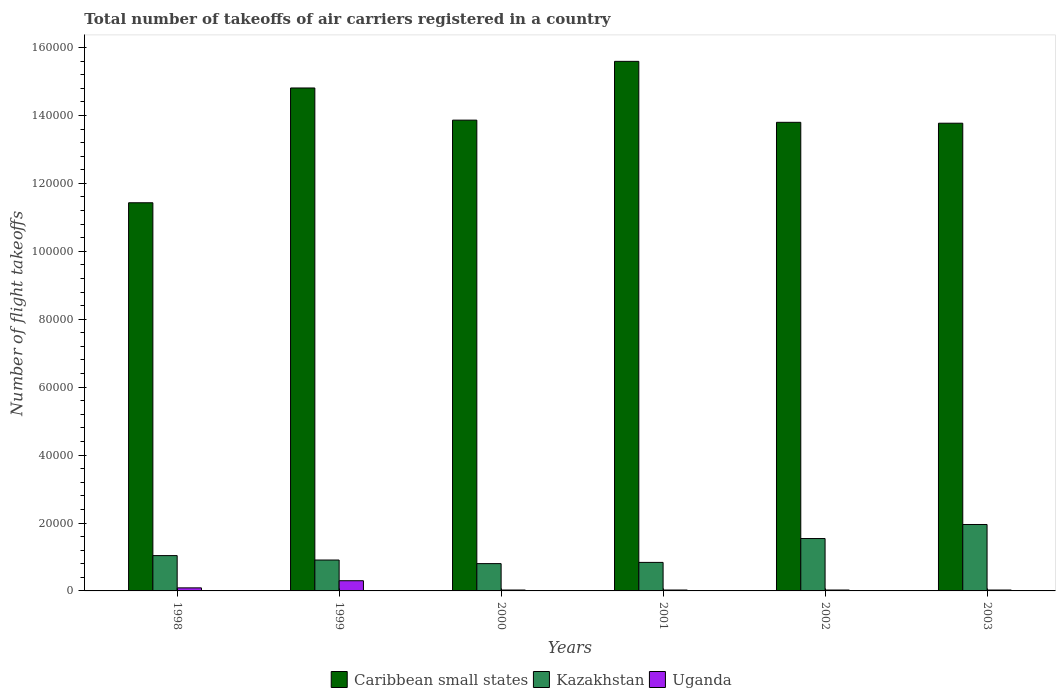How many different coloured bars are there?
Provide a succinct answer. 3. What is the label of the 1st group of bars from the left?
Provide a short and direct response. 1998. In how many cases, is the number of bars for a given year not equal to the number of legend labels?
Provide a succinct answer. 0. What is the total number of flight takeoffs in Uganda in 2002?
Keep it short and to the point. 263. Across all years, what is the maximum total number of flight takeoffs in Kazakhstan?
Offer a very short reply. 1.96e+04. Across all years, what is the minimum total number of flight takeoffs in Caribbean small states?
Offer a very short reply. 1.14e+05. In which year was the total number of flight takeoffs in Caribbean small states minimum?
Provide a succinct answer. 1998. What is the total total number of flight takeoffs in Kazakhstan in the graph?
Your answer should be very brief. 7.09e+04. What is the difference between the total number of flight takeoffs in Uganda in 2001 and that in 2002?
Offer a terse response. 3. What is the difference between the total number of flight takeoffs in Uganda in 2003 and the total number of flight takeoffs in Kazakhstan in 2002?
Offer a very short reply. -1.52e+04. What is the average total number of flight takeoffs in Caribbean small states per year?
Ensure brevity in your answer.  1.39e+05. In the year 1998, what is the difference between the total number of flight takeoffs in Uganda and total number of flight takeoffs in Kazakhstan?
Keep it short and to the point. -9500. What is the ratio of the total number of flight takeoffs in Caribbean small states in 2002 to that in 2003?
Provide a succinct answer. 1. Is the total number of flight takeoffs in Uganda in 1999 less than that in 2003?
Provide a succinct answer. No. Is the difference between the total number of flight takeoffs in Uganda in 1998 and 2001 greater than the difference between the total number of flight takeoffs in Kazakhstan in 1998 and 2001?
Ensure brevity in your answer.  No. What is the difference between the highest and the second highest total number of flight takeoffs in Kazakhstan?
Keep it short and to the point. 4134. What is the difference between the highest and the lowest total number of flight takeoffs in Caribbean small states?
Your answer should be very brief. 4.16e+04. In how many years, is the total number of flight takeoffs in Uganda greater than the average total number of flight takeoffs in Uganda taken over all years?
Keep it short and to the point. 2. Is the sum of the total number of flight takeoffs in Uganda in 1998 and 2002 greater than the maximum total number of flight takeoffs in Kazakhstan across all years?
Offer a very short reply. No. What does the 3rd bar from the left in 2002 represents?
Keep it short and to the point. Uganda. What does the 2nd bar from the right in 2000 represents?
Ensure brevity in your answer.  Kazakhstan. Is it the case that in every year, the sum of the total number of flight takeoffs in Caribbean small states and total number of flight takeoffs in Uganda is greater than the total number of flight takeoffs in Kazakhstan?
Make the answer very short. Yes. Are all the bars in the graph horizontal?
Your answer should be compact. No. How many years are there in the graph?
Your response must be concise. 6. What is the difference between two consecutive major ticks on the Y-axis?
Your response must be concise. 2.00e+04. Are the values on the major ticks of Y-axis written in scientific E-notation?
Your answer should be very brief. No. Does the graph contain any zero values?
Offer a terse response. No. Does the graph contain grids?
Your answer should be compact. No. Where does the legend appear in the graph?
Make the answer very short. Bottom center. How many legend labels are there?
Keep it short and to the point. 3. What is the title of the graph?
Provide a short and direct response. Total number of takeoffs of air carriers registered in a country. What is the label or title of the Y-axis?
Keep it short and to the point. Number of flight takeoffs. What is the Number of flight takeoffs of Caribbean small states in 1998?
Your response must be concise. 1.14e+05. What is the Number of flight takeoffs of Kazakhstan in 1998?
Your answer should be very brief. 1.04e+04. What is the Number of flight takeoffs of Uganda in 1998?
Make the answer very short. 900. What is the Number of flight takeoffs in Caribbean small states in 1999?
Provide a short and direct response. 1.48e+05. What is the Number of flight takeoffs of Kazakhstan in 1999?
Offer a terse response. 9100. What is the Number of flight takeoffs in Uganda in 1999?
Provide a short and direct response. 3000. What is the Number of flight takeoffs in Caribbean small states in 2000?
Your answer should be compact. 1.39e+05. What is the Number of flight takeoffs in Kazakhstan in 2000?
Give a very brief answer. 8041. What is the Number of flight takeoffs of Uganda in 2000?
Your response must be concise. 263. What is the Number of flight takeoffs in Caribbean small states in 2001?
Your answer should be compact. 1.56e+05. What is the Number of flight takeoffs in Kazakhstan in 2001?
Your response must be concise. 8398. What is the Number of flight takeoffs of Uganda in 2001?
Provide a short and direct response. 266. What is the Number of flight takeoffs in Caribbean small states in 2002?
Give a very brief answer. 1.38e+05. What is the Number of flight takeoffs in Kazakhstan in 2002?
Ensure brevity in your answer.  1.54e+04. What is the Number of flight takeoffs of Uganda in 2002?
Offer a very short reply. 263. What is the Number of flight takeoffs of Caribbean small states in 2003?
Provide a succinct answer. 1.38e+05. What is the Number of flight takeoffs of Kazakhstan in 2003?
Keep it short and to the point. 1.96e+04. What is the Number of flight takeoffs in Uganda in 2003?
Your answer should be compact. 263. Across all years, what is the maximum Number of flight takeoffs in Caribbean small states?
Your response must be concise. 1.56e+05. Across all years, what is the maximum Number of flight takeoffs in Kazakhstan?
Provide a short and direct response. 1.96e+04. Across all years, what is the maximum Number of flight takeoffs in Uganda?
Make the answer very short. 3000. Across all years, what is the minimum Number of flight takeoffs in Caribbean small states?
Offer a terse response. 1.14e+05. Across all years, what is the minimum Number of flight takeoffs in Kazakhstan?
Give a very brief answer. 8041. Across all years, what is the minimum Number of flight takeoffs in Uganda?
Give a very brief answer. 263. What is the total Number of flight takeoffs of Caribbean small states in the graph?
Offer a very short reply. 8.33e+05. What is the total Number of flight takeoffs of Kazakhstan in the graph?
Offer a very short reply. 7.09e+04. What is the total Number of flight takeoffs in Uganda in the graph?
Give a very brief answer. 4955. What is the difference between the Number of flight takeoffs in Caribbean small states in 1998 and that in 1999?
Your answer should be very brief. -3.38e+04. What is the difference between the Number of flight takeoffs in Kazakhstan in 1998 and that in 1999?
Offer a very short reply. 1300. What is the difference between the Number of flight takeoffs of Uganda in 1998 and that in 1999?
Keep it short and to the point. -2100. What is the difference between the Number of flight takeoffs in Caribbean small states in 1998 and that in 2000?
Offer a very short reply. -2.43e+04. What is the difference between the Number of flight takeoffs of Kazakhstan in 1998 and that in 2000?
Your answer should be compact. 2359. What is the difference between the Number of flight takeoffs of Uganda in 1998 and that in 2000?
Provide a short and direct response. 637. What is the difference between the Number of flight takeoffs of Caribbean small states in 1998 and that in 2001?
Your response must be concise. -4.16e+04. What is the difference between the Number of flight takeoffs in Kazakhstan in 1998 and that in 2001?
Provide a succinct answer. 2002. What is the difference between the Number of flight takeoffs in Uganda in 1998 and that in 2001?
Offer a very short reply. 634. What is the difference between the Number of flight takeoffs of Caribbean small states in 1998 and that in 2002?
Offer a very short reply. -2.37e+04. What is the difference between the Number of flight takeoffs of Kazakhstan in 1998 and that in 2002?
Give a very brief answer. -5026. What is the difference between the Number of flight takeoffs in Uganda in 1998 and that in 2002?
Provide a short and direct response. 637. What is the difference between the Number of flight takeoffs in Caribbean small states in 1998 and that in 2003?
Offer a very short reply. -2.34e+04. What is the difference between the Number of flight takeoffs in Kazakhstan in 1998 and that in 2003?
Ensure brevity in your answer.  -9160. What is the difference between the Number of flight takeoffs of Uganda in 1998 and that in 2003?
Provide a short and direct response. 637. What is the difference between the Number of flight takeoffs of Caribbean small states in 1999 and that in 2000?
Make the answer very short. 9468. What is the difference between the Number of flight takeoffs of Kazakhstan in 1999 and that in 2000?
Give a very brief answer. 1059. What is the difference between the Number of flight takeoffs of Uganda in 1999 and that in 2000?
Provide a short and direct response. 2737. What is the difference between the Number of flight takeoffs of Caribbean small states in 1999 and that in 2001?
Provide a succinct answer. -7840. What is the difference between the Number of flight takeoffs of Kazakhstan in 1999 and that in 2001?
Your answer should be very brief. 702. What is the difference between the Number of flight takeoffs in Uganda in 1999 and that in 2001?
Ensure brevity in your answer.  2734. What is the difference between the Number of flight takeoffs of Caribbean small states in 1999 and that in 2002?
Your answer should be very brief. 1.01e+04. What is the difference between the Number of flight takeoffs in Kazakhstan in 1999 and that in 2002?
Offer a very short reply. -6326. What is the difference between the Number of flight takeoffs of Uganda in 1999 and that in 2002?
Your response must be concise. 2737. What is the difference between the Number of flight takeoffs of Caribbean small states in 1999 and that in 2003?
Provide a short and direct response. 1.04e+04. What is the difference between the Number of flight takeoffs of Kazakhstan in 1999 and that in 2003?
Your response must be concise. -1.05e+04. What is the difference between the Number of flight takeoffs in Uganda in 1999 and that in 2003?
Offer a very short reply. 2737. What is the difference between the Number of flight takeoffs in Caribbean small states in 2000 and that in 2001?
Keep it short and to the point. -1.73e+04. What is the difference between the Number of flight takeoffs of Kazakhstan in 2000 and that in 2001?
Your answer should be very brief. -357. What is the difference between the Number of flight takeoffs of Uganda in 2000 and that in 2001?
Make the answer very short. -3. What is the difference between the Number of flight takeoffs in Caribbean small states in 2000 and that in 2002?
Ensure brevity in your answer.  645. What is the difference between the Number of flight takeoffs of Kazakhstan in 2000 and that in 2002?
Provide a short and direct response. -7385. What is the difference between the Number of flight takeoffs of Uganda in 2000 and that in 2002?
Provide a short and direct response. 0. What is the difference between the Number of flight takeoffs in Caribbean small states in 2000 and that in 2003?
Keep it short and to the point. 905. What is the difference between the Number of flight takeoffs of Kazakhstan in 2000 and that in 2003?
Make the answer very short. -1.15e+04. What is the difference between the Number of flight takeoffs of Caribbean small states in 2001 and that in 2002?
Keep it short and to the point. 1.80e+04. What is the difference between the Number of flight takeoffs of Kazakhstan in 2001 and that in 2002?
Provide a short and direct response. -7028. What is the difference between the Number of flight takeoffs of Uganda in 2001 and that in 2002?
Make the answer very short. 3. What is the difference between the Number of flight takeoffs of Caribbean small states in 2001 and that in 2003?
Ensure brevity in your answer.  1.82e+04. What is the difference between the Number of flight takeoffs of Kazakhstan in 2001 and that in 2003?
Ensure brevity in your answer.  -1.12e+04. What is the difference between the Number of flight takeoffs of Uganda in 2001 and that in 2003?
Your answer should be compact. 3. What is the difference between the Number of flight takeoffs of Caribbean small states in 2002 and that in 2003?
Provide a short and direct response. 260. What is the difference between the Number of flight takeoffs of Kazakhstan in 2002 and that in 2003?
Keep it short and to the point. -4134. What is the difference between the Number of flight takeoffs of Uganda in 2002 and that in 2003?
Give a very brief answer. 0. What is the difference between the Number of flight takeoffs of Caribbean small states in 1998 and the Number of flight takeoffs of Kazakhstan in 1999?
Offer a very short reply. 1.05e+05. What is the difference between the Number of flight takeoffs in Caribbean small states in 1998 and the Number of flight takeoffs in Uganda in 1999?
Offer a terse response. 1.11e+05. What is the difference between the Number of flight takeoffs of Kazakhstan in 1998 and the Number of flight takeoffs of Uganda in 1999?
Give a very brief answer. 7400. What is the difference between the Number of flight takeoffs in Caribbean small states in 1998 and the Number of flight takeoffs in Kazakhstan in 2000?
Make the answer very short. 1.06e+05. What is the difference between the Number of flight takeoffs of Caribbean small states in 1998 and the Number of flight takeoffs of Uganda in 2000?
Provide a short and direct response. 1.14e+05. What is the difference between the Number of flight takeoffs of Kazakhstan in 1998 and the Number of flight takeoffs of Uganda in 2000?
Make the answer very short. 1.01e+04. What is the difference between the Number of flight takeoffs of Caribbean small states in 1998 and the Number of flight takeoffs of Kazakhstan in 2001?
Make the answer very short. 1.06e+05. What is the difference between the Number of flight takeoffs in Caribbean small states in 1998 and the Number of flight takeoffs in Uganda in 2001?
Ensure brevity in your answer.  1.14e+05. What is the difference between the Number of flight takeoffs in Kazakhstan in 1998 and the Number of flight takeoffs in Uganda in 2001?
Your response must be concise. 1.01e+04. What is the difference between the Number of flight takeoffs of Caribbean small states in 1998 and the Number of flight takeoffs of Kazakhstan in 2002?
Provide a succinct answer. 9.89e+04. What is the difference between the Number of flight takeoffs in Caribbean small states in 1998 and the Number of flight takeoffs in Uganda in 2002?
Your answer should be compact. 1.14e+05. What is the difference between the Number of flight takeoffs in Kazakhstan in 1998 and the Number of flight takeoffs in Uganda in 2002?
Keep it short and to the point. 1.01e+04. What is the difference between the Number of flight takeoffs of Caribbean small states in 1998 and the Number of flight takeoffs of Kazakhstan in 2003?
Your answer should be very brief. 9.47e+04. What is the difference between the Number of flight takeoffs in Caribbean small states in 1998 and the Number of flight takeoffs in Uganda in 2003?
Make the answer very short. 1.14e+05. What is the difference between the Number of flight takeoffs in Kazakhstan in 1998 and the Number of flight takeoffs in Uganda in 2003?
Ensure brevity in your answer.  1.01e+04. What is the difference between the Number of flight takeoffs in Caribbean small states in 1999 and the Number of flight takeoffs in Kazakhstan in 2000?
Ensure brevity in your answer.  1.40e+05. What is the difference between the Number of flight takeoffs in Caribbean small states in 1999 and the Number of flight takeoffs in Uganda in 2000?
Give a very brief answer. 1.48e+05. What is the difference between the Number of flight takeoffs of Kazakhstan in 1999 and the Number of flight takeoffs of Uganda in 2000?
Keep it short and to the point. 8837. What is the difference between the Number of flight takeoffs of Caribbean small states in 1999 and the Number of flight takeoffs of Kazakhstan in 2001?
Provide a succinct answer. 1.40e+05. What is the difference between the Number of flight takeoffs in Caribbean small states in 1999 and the Number of flight takeoffs in Uganda in 2001?
Your answer should be compact. 1.48e+05. What is the difference between the Number of flight takeoffs of Kazakhstan in 1999 and the Number of flight takeoffs of Uganda in 2001?
Provide a succinct answer. 8834. What is the difference between the Number of flight takeoffs of Caribbean small states in 1999 and the Number of flight takeoffs of Kazakhstan in 2002?
Keep it short and to the point. 1.33e+05. What is the difference between the Number of flight takeoffs in Caribbean small states in 1999 and the Number of flight takeoffs in Uganda in 2002?
Provide a succinct answer. 1.48e+05. What is the difference between the Number of flight takeoffs of Kazakhstan in 1999 and the Number of flight takeoffs of Uganda in 2002?
Your answer should be compact. 8837. What is the difference between the Number of flight takeoffs of Caribbean small states in 1999 and the Number of flight takeoffs of Kazakhstan in 2003?
Your response must be concise. 1.29e+05. What is the difference between the Number of flight takeoffs of Caribbean small states in 1999 and the Number of flight takeoffs of Uganda in 2003?
Offer a terse response. 1.48e+05. What is the difference between the Number of flight takeoffs of Kazakhstan in 1999 and the Number of flight takeoffs of Uganda in 2003?
Provide a short and direct response. 8837. What is the difference between the Number of flight takeoffs of Caribbean small states in 2000 and the Number of flight takeoffs of Kazakhstan in 2001?
Provide a succinct answer. 1.30e+05. What is the difference between the Number of flight takeoffs of Caribbean small states in 2000 and the Number of flight takeoffs of Uganda in 2001?
Make the answer very short. 1.38e+05. What is the difference between the Number of flight takeoffs in Kazakhstan in 2000 and the Number of flight takeoffs in Uganda in 2001?
Provide a succinct answer. 7775. What is the difference between the Number of flight takeoffs in Caribbean small states in 2000 and the Number of flight takeoffs in Kazakhstan in 2002?
Your answer should be very brief. 1.23e+05. What is the difference between the Number of flight takeoffs in Caribbean small states in 2000 and the Number of flight takeoffs in Uganda in 2002?
Offer a terse response. 1.38e+05. What is the difference between the Number of flight takeoffs of Kazakhstan in 2000 and the Number of flight takeoffs of Uganda in 2002?
Offer a very short reply. 7778. What is the difference between the Number of flight takeoffs in Caribbean small states in 2000 and the Number of flight takeoffs in Kazakhstan in 2003?
Make the answer very short. 1.19e+05. What is the difference between the Number of flight takeoffs in Caribbean small states in 2000 and the Number of flight takeoffs in Uganda in 2003?
Keep it short and to the point. 1.38e+05. What is the difference between the Number of flight takeoffs of Kazakhstan in 2000 and the Number of flight takeoffs of Uganda in 2003?
Give a very brief answer. 7778. What is the difference between the Number of flight takeoffs of Caribbean small states in 2001 and the Number of flight takeoffs of Kazakhstan in 2002?
Your answer should be compact. 1.41e+05. What is the difference between the Number of flight takeoffs of Caribbean small states in 2001 and the Number of flight takeoffs of Uganda in 2002?
Offer a very short reply. 1.56e+05. What is the difference between the Number of flight takeoffs in Kazakhstan in 2001 and the Number of flight takeoffs in Uganda in 2002?
Your answer should be very brief. 8135. What is the difference between the Number of flight takeoffs of Caribbean small states in 2001 and the Number of flight takeoffs of Kazakhstan in 2003?
Your answer should be very brief. 1.36e+05. What is the difference between the Number of flight takeoffs in Caribbean small states in 2001 and the Number of flight takeoffs in Uganda in 2003?
Offer a terse response. 1.56e+05. What is the difference between the Number of flight takeoffs of Kazakhstan in 2001 and the Number of flight takeoffs of Uganda in 2003?
Give a very brief answer. 8135. What is the difference between the Number of flight takeoffs of Caribbean small states in 2002 and the Number of flight takeoffs of Kazakhstan in 2003?
Ensure brevity in your answer.  1.18e+05. What is the difference between the Number of flight takeoffs in Caribbean small states in 2002 and the Number of flight takeoffs in Uganda in 2003?
Ensure brevity in your answer.  1.38e+05. What is the difference between the Number of flight takeoffs of Kazakhstan in 2002 and the Number of flight takeoffs of Uganda in 2003?
Give a very brief answer. 1.52e+04. What is the average Number of flight takeoffs in Caribbean small states per year?
Give a very brief answer. 1.39e+05. What is the average Number of flight takeoffs of Kazakhstan per year?
Your answer should be compact. 1.18e+04. What is the average Number of flight takeoffs in Uganda per year?
Provide a succinct answer. 825.83. In the year 1998, what is the difference between the Number of flight takeoffs in Caribbean small states and Number of flight takeoffs in Kazakhstan?
Your answer should be compact. 1.04e+05. In the year 1998, what is the difference between the Number of flight takeoffs of Caribbean small states and Number of flight takeoffs of Uganda?
Give a very brief answer. 1.13e+05. In the year 1998, what is the difference between the Number of flight takeoffs of Kazakhstan and Number of flight takeoffs of Uganda?
Give a very brief answer. 9500. In the year 1999, what is the difference between the Number of flight takeoffs in Caribbean small states and Number of flight takeoffs in Kazakhstan?
Your answer should be very brief. 1.39e+05. In the year 1999, what is the difference between the Number of flight takeoffs of Caribbean small states and Number of flight takeoffs of Uganda?
Provide a succinct answer. 1.45e+05. In the year 1999, what is the difference between the Number of flight takeoffs in Kazakhstan and Number of flight takeoffs in Uganda?
Your response must be concise. 6100. In the year 2000, what is the difference between the Number of flight takeoffs of Caribbean small states and Number of flight takeoffs of Kazakhstan?
Give a very brief answer. 1.31e+05. In the year 2000, what is the difference between the Number of flight takeoffs of Caribbean small states and Number of flight takeoffs of Uganda?
Make the answer very short. 1.38e+05. In the year 2000, what is the difference between the Number of flight takeoffs in Kazakhstan and Number of flight takeoffs in Uganda?
Offer a very short reply. 7778. In the year 2001, what is the difference between the Number of flight takeoffs in Caribbean small states and Number of flight takeoffs in Kazakhstan?
Keep it short and to the point. 1.48e+05. In the year 2001, what is the difference between the Number of flight takeoffs of Caribbean small states and Number of flight takeoffs of Uganda?
Give a very brief answer. 1.56e+05. In the year 2001, what is the difference between the Number of flight takeoffs in Kazakhstan and Number of flight takeoffs in Uganda?
Provide a succinct answer. 8132. In the year 2002, what is the difference between the Number of flight takeoffs in Caribbean small states and Number of flight takeoffs in Kazakhstan?
Your answer should be compact. 1.23e+05. In the year 2002, what is the difference between the Number of flight takeoffs in Caribbean small states and Number of flight takeoffs in Uganda?
Provide a succinct answer. 1.38e+05. In the year 2002, what is the difference between the Number of flight takeoffs in Kazakhstan and Number of flight takeoffs in Uganda?
Keep it short and to the point. 1.52e+04. In the year 2003, what is the difference between the Number of flight takeoffs in Caribbean small states and Number of flight takeoffs in Kazakhstan?
Make the answer very short. 1.18e+05. In the year 2003, what is the difference between the Number of flight takeoffs of Caribbean small states and Number of flight takeoffs of Uganda?
Keep it short and to the point. 1.37e+05. In the year 2003, what is the difference between the Number of flight takeoffs of Kazakhstan and Number of flight takeoffs of Uganda?
Provide a succinct answer. 1.93e+04. What is the ratio of the Number of flight takeoffs of Caribbean small states in 1998 to that in 1999?
Offer a very short reply. 0.77. What is the ratio of the Number of flight takeoffs in Caribbean small states in 1998 to that in 2000?
Provide a succinct answer. 0.82. What is the ratio of the Number of flight takeoffs in Kazakhstan in 1998 to that in 2000?
Make the answer very short. 1.29. What is the ratio of the Number of flight takeoffs in Uganda in 1998 to that in 2000?
Ensure brevity in your answer.  3.42. What is the ratio of the Number of flight takeoffs of Caribbean small states in 1998 to that in 2001?
Give a very brief answer. 0.73. What is the ratio of the Number of flight takeoffs of Kazakhstan in 1998 to that in 2001?
Your response must be concise. 1.24. What is the ratio of the Number of flight takeoffs in Uganda in 1998 to that in 2001?
Provide a short and direct response. 3.38. What is the ratio of the Number of flight takeoffs in Caribbean small states in 1998 to that in 2002?
Your answer should be very brief. 0.83. What is the ratio of the Number of flight takeoffs of Kazakhstan in 1998 to that in 2002?
Your answer should be compact. 0.67. What is the ratio of the Number of flight takeoffs in Uganda in 1998 to that in 2002?
Ensure brevity in your answer.  3.42. What is the ratio of the Number of flight takeoffs in Caribbean small states in 1998 to that in 2003?
Keep it short and to the point. 0.83. What is the ratio of the Number of flight takeoffs of Kazakhstan in 1998 to that in 2003?
Offer a very short reply. 0.53. What is the ratio of the Number of flight takeoffs in Uganda in 1998 to that in 2003?
Ensure brevity in your answer.  3.42. What is the ratio of the Number of flight takeoffs in Caribbean small states in 1999 to that in 2000?
Your answer should be very brief. 1.07. What is the ratio of the Number of flight takeoffs of Kazakhstan in 1999 to that in 2000?
Keep it short and to the point. 1.13. What is the ratio of the Number of flight takeoffs of Uganda in 1999 to that in 2000?
Offer a terse response. 11.41. What is the ratio of the Number of flight takeoffs of Caribbean small states in 1999 to that in 2001?
Keep it short and to the point. 0.95. What is the ratio of the Number of flight takeoffs of Kazakhstan in 1999 to that in 2001?
Your answer should be very brief. 1.08. What is the ratio of the Number of flight takeoffs in Uganda in 1999 to that in 2001?
Make the answer very short. 11.28. What is the ratio of the Number of flight takeoffs of Caribbean small states in 1999 to that in 2002?
Your answer should be very brief. 1.07. What is the ratio of the Number of flight takeoffs of Kazakhstan in 1999 to that in 2002?
Your answer should be compact. 0.59. What is the ratio of the Number of flight takeoffs in Uganda in 1999 to that in 2002?
Provide a short and direct response. 11.41. What is the ratio of the Number of flight takeoffs in Caribbean small states in 1999 to that in 2003?
Your answer should be compact. 1.08. What is the ratio of the Number of flight takeoffs in Kazakhstan in 1999 to that in 2003?
Offer a very short reply. 0.47. What is the ratio of the Number of flight takeoffs in Uganda in 1999 to that in 2003?
Provide a short and direct response. 11.41. What is the ratio of the Number of flight takeoffs of Caribbean small states in 2000 to that in 2001?
Offer a terse response. 0.89. What is the ratio of the Number of flight takeoffs in Kazakhstan in 2000 to that in 2001?
Make the answer very short. 0.96. What is the ratio of the Number of flight takeoffs of Uganda in 2000 to that in 2001?
Ensure brevity in your answer.  0.99. What is the ratio of the Number of flight takeoffs of Caribbean small states in 2000 to that in 2002?
Your answer should be very brief. 1. What is the ratio of the Number of flight takeoffs of Kazakhstan in 2000 to that in 2002?
Your answer should be very brief. 0.52. What is the ratio of the Number of flight takeoffs of Uganda in 2000 to that in 2002?
Keep it short and to the point. 1. What is the ratio of the Number of flight takeoffs in Caribbean small states in 2000 to that in 2003?
Give a very brief answer. 1.01. What is the ratio of the Number of flight takeoffs of Kazakhstan in 2000 to that in 2003?
Ensure brevity in your answer.  0.41. What is the ratio of the Number of flight takeoffs in Caribbean small states in 2001 to that in 2002?
Your response must be concise. 1.13. What is the ratio of the Number of flight takeoffs of Kazakhstan in 2001 to that in 2002?
Your answer should be very brief. 0.54. What is the ratio of the Number of flight takeoffs in Uganda in 2001 to that in 2002?
Provide a short and direct response. 1.01. What is the ratio of the Number of flight takeoffs of Caribbean small states in 2001 to that in 2003?
Provide a succinct answer. 1.13. What is the ratio of the Number of flight takeoffs in Kazakhstan in 2001 to that in 2003?
Ensure brevity in your answer.  0.43. What is the ratio of the Number of flight takeoffs in Uganda in 2001 to that in 2003?
Your answer should be compact. 1.01. What is the ratio of the Number of flight takeoffs of Caribbean small states in 2002 to that in 2003?
Provide a succinct answer. 1. What is the ratio of the Number of flight takeoffs in Kazakhstan in 2002 to that in 2003?
Your response must be concise. 0.79. What is the ratio of the Number of flight takeoffs in Uganda in 2002 to that in 2003?
Provide a short and direct response. 1. What is the difference between the highest and the second highest Number of flight takeoffs in Caribbean small states?
Offer a very short reply. 7840. What is the difference between the highest and the second highest Number of flight takeoffs of Kazakhstan?
Offer a terse response. 4134. What is the difference between the highest and the second highest Number of flight takeoffs in Uganda?
Your response must be concise. 2100. What is the difference between the highest and the lowest Number of flight takeoffs of Caribbean small states?
Your answer should be compact. 4.16e+04. What is the difference between the highest and the lowest Number of flight takeoffs of Kazakhstan?
Provide a short and direct response. 1.15e+04. What is the difference between the highest and the lowest Number of flight takeoffs in Uganda?
Provide a succinct answer. 2737. 